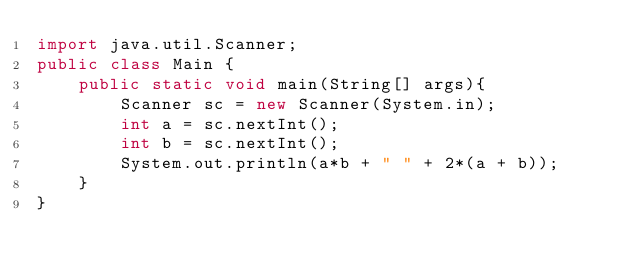<code> <loc_0><loc_0><loc_500><loc_500><_Java_>import java.util.Scanner;
public class Main {
	public static void main(String[] args){
		Scanner sc = new Scanner(System.in);
		int a = sc.nextInt();
		int b = sc.nextInt();
		System.out.println(a*b + " " + 2*(a + b));
	}
}

</code> 